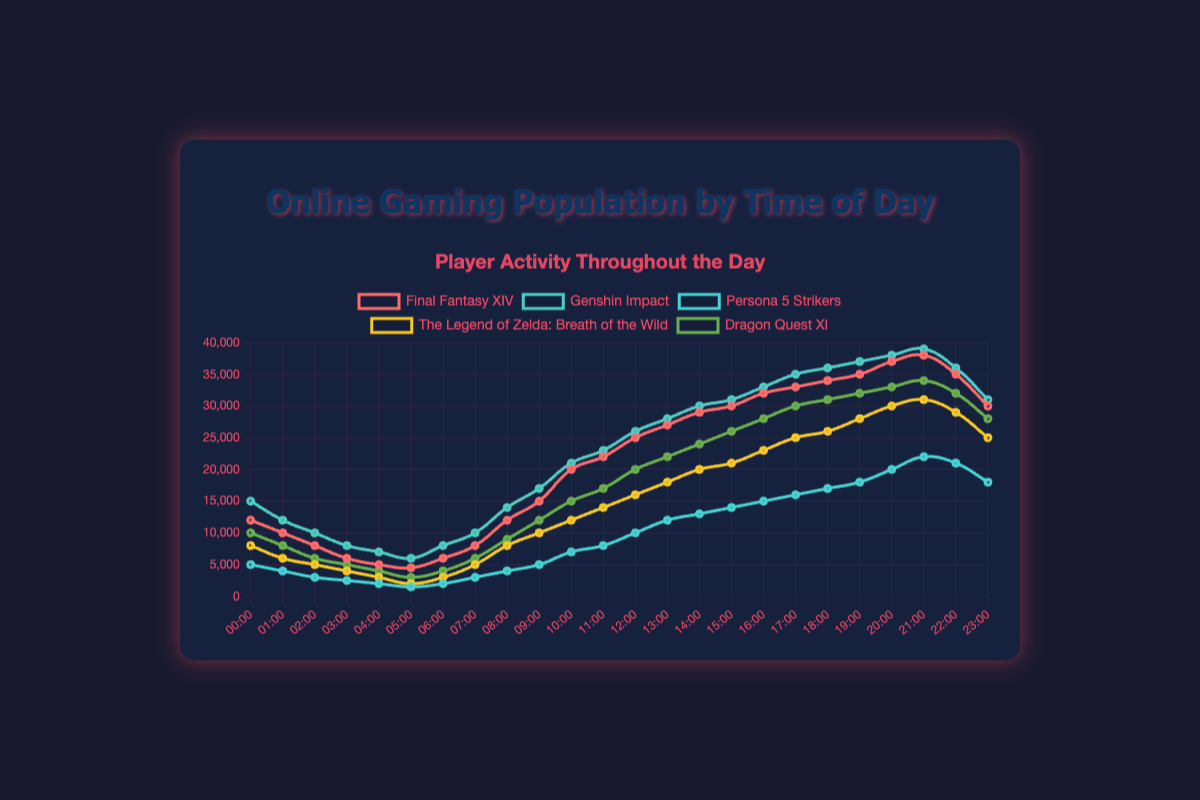What time of day has the highest number of players online for Genshin Impact? The peak number of online players for Genshin Impact is when it reaches 39,000 players. This occurs at 21:00.
Answer: 21:00 How does the number of players online at 12:00 compare between Final Fantasy XIV and Persona 5 Strikers? At 12:00, Final Fantasy XIV has 25,000 players online, while Persona 5 Strikers has 10,000 players online. Final Fantasy XIV has 15,000 more players than Persona 5 Strikers at this time.
Answer: Final Fantasy XIV has 15,000 more players Which game has the steepest increase in players online from 10:00 to 11:00? Between 10:00 and 11:00, Dragon Quest XI goes from 15,000 to 17,000 players, an increase of 2,000. Final Fantasy XIV goes from 20,000 to 22,000, also an increase of 2,000. Other games increase by lesser amounts during this time interval, making it a tie between Dragon Quest XI and Final Fantasy XIV.
Answer: Dragon Quest XI and Final Fantasy XIV What is the average number of online players for The Legend of Zelda: Breath of the Wild from 00:00 to 05:00? The number of players online for The Legend of Zelda from 00:00 to 05:00 are 8,000, 6,000, 5,000, 4,000, and 3,000 respectively. The average is calculated as (8,000 + 6,000 + 5,000 + 4,000 + 3,000) / 5 = 26,000 / 5 = 5,200 players.
Answer: 5,200 players Which game shows a consistent increase in online players from 00:00 to 23:00 without any drop? All games experience some fluctuation in player numbers throughout the day. However, the game that most closely approximates a consistent increase is Genshin Impact, which shows only slight decreases and overall upward trends.
Answer: None (Genshin Impact nearly) How many players are online in total across all games at 18:00? At 18:00, Final Fantasy XIV has 34,000 players, Genshin Impact has 36,000 players, Persona 5 Strikers has 17,000 players, The Legend of Zelda: Breath of the Wild has 26,000 players, and Dragon Quest XI has 31,000 players. The total is 34,000 + 36,000 + 17,000 + 26,000 + 31,000 = 144,000 players.
Answer: 144,000 players Compare the fluctuation in player counts for Persona 5 Strikers and Dragon Quest XI at 22:00 and 23:00. At 22:00, Persona 5 Strikers has 21,000 players while at 23:00 it drops to 18,000, a decrease of 3,000. Dragon Quest XI has 32,000 players at 22:00 and 28,000 players at 23:00, decreasing by 4,000. Dragon Quest XI shows a higher fluctuation than Persona 5 Strikers.
Answer: Dragon Quest XI has a higher fluctuation At what time do Final Fantasy XIV and The Legend of Zelda: Breath of the Wild have the same number of online players? Both Final Fantasy XIV and The Legend of Zelda: Breath of the Wild have 8,000 online players at 08:00.
Answer: 08:00 